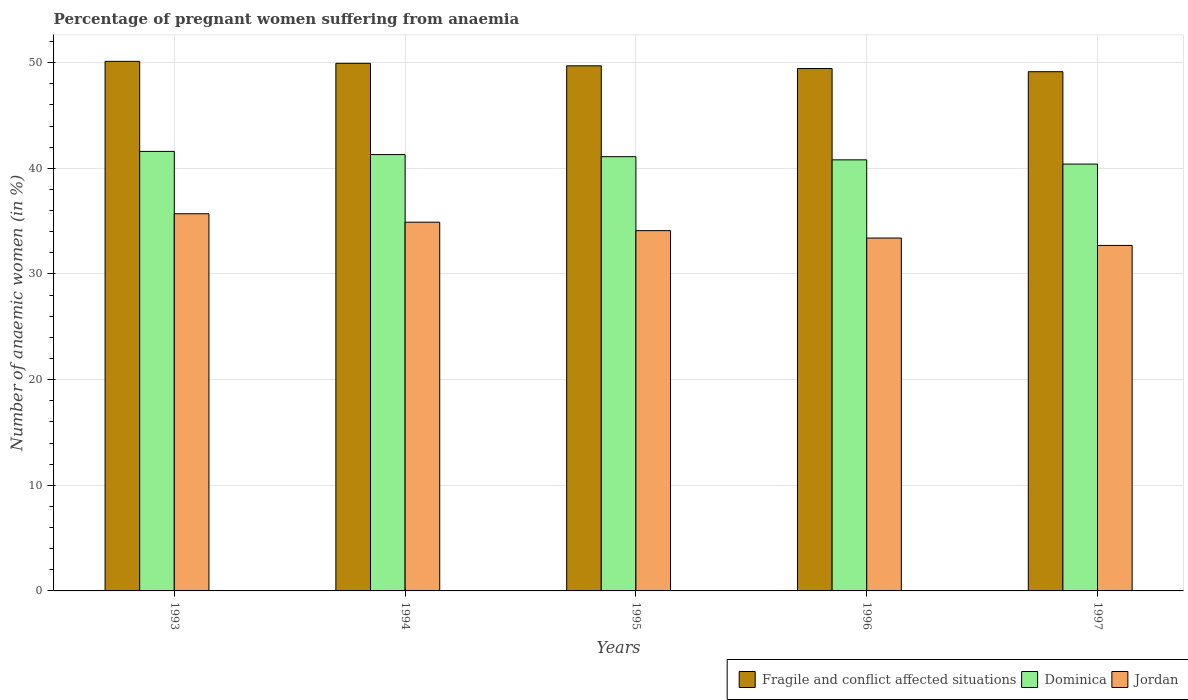How many groups of bars are there?
Provide a short and direct response. 5. How many bars are there on the 4th tick from the left?
Keep it short and to the point. 3. How many bars are there on the 1st tick from the right?
Give a very brief answer. 3. In how many cases, is the number of bars for a given year not equal to the number of legend labels?
Keep it short and to the point. 0. What is the number of anaemic women in Dominica in 1997?
Provide a succinct answer. 40.4. Across all years, what is the maximum number of anaemic women in Jordan?
Offer a terse response. 35.7. Across all years, what is the minimum number of anaemic women in Fragile and conflict affected situations?
Keep it short and to the point. 49.14. What is the total number of anaemic women in Dominica in the graph?
Offer a very short reply. 205.2. What is the difference between the number of anaemic women in Dominica in 1993 and the number of anaemic women in Fragile and conflict affected situations in 1995?
Your answer should be compact. -8.1. What is the average number of anaemic women in Fragile and conflict affected situations per year?
Keep it short and to the point. 49.67. In the year 1997, what is the difference between the number of anaemic women in Fragile and conflict affected situations and number of anaemic women in Jordan?
Offer a terse response. 16.44. In how many years, is the number of anaemic women in Jordan greater than 14 %?
Provide a succinct answer. 5. What is the ratio of the number of anaemic women in Fragile and conflict affected situations in 1994 to that in 1997?
Keep it short and to the point. 1.02. What is the difference between the highest and the second highest number of anaemic women in Jordan?
Your answer should be very brief. 0.8. What is the difference between the highest and the lowest number of anaemic women in Jordan?
Your response must be concise. 3. In how many years, is the number of anaemic women in Jordan greater than the average number of anaemic women in Jordan taken over all years?
Offer a very short reply. 2. What does the 3rd bar from the left in 1995 represents?
Make the answer very short. Jordan. What does the 1st bar from the right in 1996 represents?
Your answer should be compact. Jordan. Is it the case that in every year, the sum of the number of anaemic women in Dominica and number of anaemic women in Fragile and conflict affected situations is greater than the number of anaemic women in Jordan?
Your answer should be compact. Yes. How many bars are there?
Your answer should be very brief. 15. Are all the bars in the graph horizontal?
Your response must be concise. No. Does the graph contain grids?
Offer a very short reply. Yes. Where does the legend appear in the graph?
Make the answer very short. Bottom right. How many legend labels are there?
Your answer should be compact. 3. How are the legend labels stacked?
Keep it short and to the point. Horizontal. What is the title of the graph?
Offer a terse response. Percentage of pregnant women suffering from anaemia. Does "Ghana" appear as one of the legend labels in the graph?
Your answer should be very brief. No. What is the label or title of the X-axis?
Give a very brief answer. Years. What is the label or title of the Y-axis?
Your answer should be very brief. Number of anaemic women (in %). What is the Number of anaemic women (in %) in Fragile and conflict affected situations in 1993?
Provide a succinct answer. 50.12. What is the Number of anaemic women (in %) of Dominica in 1993?
Give a very brief answer. 41.6. What is the Number of anaemic women (in %) in Jordan in 1993?
Make the answer very short. 35.7. What is the Number of anaemic women (in %) of Fragile and conflict affected situations in 1994?
Keep it short and to the point. 49.94. What is the Number of anaemic women (in %) in Dominica in 1994?
Keep it short and to the point. 41.3. What is the Number of anaemic women (in %) of Jordan in 1994?
Your answer should be compact. 34.9. What is the Number of anaemic women (in %) of Fragile and conflict affected situations in 1995?
Your response must be concise. 49.7. What is the Number of anaemic women (in %) in Dominica in 1995?
Offer a terse response. 41.1. What is the Number of anaemic women (in %) of Jordan in 1995?
Provide a succinct answer. 34.1. What is the Number of anaemic women (in %) of Fragile and conflict affected situations in 1996?
Offer a very short reply. 49.44. What is the Number of anaemic women (in %) in Dominica in 1996?
Your answer should be very brief. 40.8. What is the Number of anaemic women (in %) of Jordan in 1996?
Your answer should be very brief. 33.4. What is the Number of anaemic women (in %) of Fragile and conflict affected situations in 1997?
Keep it short and to the point. 49.14. What is the Number of anaemic women (in %) in Dominica in 1997?
Make the answer very short. 40.4. What is the Number of anaemic women (in %) in Jordan in 1997?
Give a very brief answer. 32.7. Across all years, what is the maximum Number of anaemic women (in %) in Fragile and conflict affected situations?
Provide a succinct answer. 50.12. Across all years, what is the maximum Number of anaemic women (in %) in Dominica?
Your response must be concise. 41.6. Across all years, what is the maximum Number of anaemic women (in %) in Jordan?
Provide a succinct answer. 35.7. Across all years, what is the minimum Number of anaemic women (in %) in Fragile and conflict affected situations?
Provide a succinct answer. 49.14. Across all years, what is the minimum Number of anaemic women (in %) in Dominica?
Keep it short and to the point. 40.4. Across all years, what is the minimum Number of anaemic women (in %) in Jordan?
Provide a short and direct response. 32.7. What is the total Number of anaemic women (in %) of Fragile and conflict affected situations in the graph?
Provide a succinct answer. 248.35. What is the total Number of anaemic women (in %) of Dominica in the graph?
Your answer should be very brief. 205.2. What is the total Number of anaemic women (in %) in Jordan in the graph?
Provide a succinct answer. 170.8. What is the difference between the Number of anaemic women (in %) in Fragile and conflict affected situations in 1993 and that in 1994?
Your answer should be very brief. 0.18. What is the difference between the Number of anaemic women (in %) of Dominica in 1993 and that in 1994?
Ensure brevity in your answer.  0.3. What is the difference between the Number of anaemic women (in %) in Fragile and conflict affected situations in 1993 and that in 1995?
Provide a succinct answer. 0.42. What is the difference between the Number of anaemic women (in %) of Dominica in 1993 and that in 1995?
Offer a terse response. 0.5. What is the difference between the Number of anaemic women (in %) of Jordan in 1993 and that in 1995?
Make the answer very short. 1.6. What is the difference between the Number of anaemic women (in %) of Fragile and conflict affected situations in 1993 and that in 1996?
Provide a succinct answer. 0.68. What is the difference between the Number of anaemic women (in %) in Dominica in 1993 and that in 1996?
Offer a terse response. 0.8. What is the difference between the Number of anaemic women (in %) of Fragile and conflict affected situations in 1993 and that in 1997?
Your answer should be compact. 0.98. What is the difference between the Number of anaemic women (in %) in Dominica in 1993 and that in 1997?
Provide a short and direct response. 1.2. What is the difference between the Number of anaemic women (in %) of Jordan in 1993 and that in 1997?
Make the answer very short. 3. What is the difference between the Number of anaemic women (in %) of Fragile and conflict affected situations in 1994 and that in 1995?
Provide a succinct answer. 0.24. What is the difference between the Number of anaemic women (in %) of Fragile and conflict affected situations in 1994 and that in 1996?
Your response must be concise. 0.49. What is the difference between the Number of anaemic women (in %) in Jordan in 1994 and that in 1996?
Ensure brevity in your answer.  1.5. What is the difference between the Number of anaemic women (in %) in Fragile and conflict affected situations in 1994 and that in 1997?
Offer a terse response. 0.8. What is the difference between the Number of anaemic women (in %) of Fragile and conflict affected situations in 1995 and that in 1996?
Provide a succinct answer. 0.26. What is the difference between the Number of anaemic women (in %) in Jordan in 1995 and that in 1996?
Provide a succinct answer. 0.7. What is the difference between the Number of anaemic women (in %) of Fragile and conflict affected situations in 1995 and that in 1997?
Provide a succinct answer. 0.56. What is the difference between the Number of anaemic women (in %) in Fragile and conflict affected situations in 1996 and that in 1997?
Give a very brief answer. 0.3. What is the difference between the Number of anaemic women (in %) of Dominica in 1996 and that in 1997?
Your answer should be compact. 0.4. What is the difference between the Number of anaemic women (in %) of Jordan in 1996 and that in 1997?
Ensure brevity in your answer.  0.7. What is the difference between the Number of anaemic women (in %) of Fragile and conflict affected situations in 1993 and the Number of anaemic women (in %) of Dominica in 1994?
Offer a terse response. 8.82. What is the difference between the Number of anaemic women (in %) in Fragile and conflict affected situations in 1993 and the Number of anaemic women (in %) in Jordan in 1994?
Keep it short and to the point. 15.22. What is the difference between the Number of anaemic women (in %) of Dominica in 1993 and the Number of anaemic women (in %) of Jordan in 1994?
Provide a short and direct response. 6.7. What is the difference between the Number of anaemic women (in %) of Fragile and conflict affected situations in 1993 and the Number of anaemic women (in %) of Dominica in 1995?
Offer a very short reply. 9.02. What is the difference between the Number of anaemic women (in %) in Fragile and conflict affected situations in 1993 and the Number of anaemic women (in %) in Jordan in 1995?
Offer a very short reply. 16.02. What is the difference between the Number of anaemic women (in %) of Dominica in 1993 and the Number of anaemic women (in %) of Jordan in 1995?
Give a very brief answer. 7.5. What is the difference between the Number of anaemic women (in %) in Fragile and conflict affected situations in 1993 and the Number of anaemic women (in %) in Dominica in 1996?
Keep it short and to the point. 9.32. What is the difference between the Number of anaemic women (in %) of Fragile and conflict affected situations in 1993 and the Number of anaemic women (in %) of Jordan in 1996?
Provide a short and direct response. 16.72. What is the difference between the Number of anaemic women (in %) of Dominica in 1993 and the Number of anaemic women (in %) of Jordan in 1996?
Provide a short and direct response. 8.2. What is the difference between the Number of anaemic women (in %) in Fragile and conflict affected situations in 1993 and the Number of anaemic women (in %) in Dominica in 1997?
Offer a very short reply. 9.72. What is the difference between the Number of anaemic women (in %) in Fragile and conflict affected situations in 1993 and the Number of anaemic women (in %) in Jordan in 1997?
Give a very brief answer. 17.42. What is the difference between the Number of anaemic women (in %) of Fragile and conflict affected situations in 1994 and the Number of anaemic women (in %) of Dominica in 1995?
Offer a very short reply. 8.84. What is the difference between the Number of anaemic women (in %) of Fragile and conflict affected situations in 1994 and the Number of anaemic women (in %) of Jordan in 1995?
Ensure brevity in your answer.  15.84. What is the difference between the Number of anaemic women (in %) of Fragile and conflict affected situations in 1994 and the Number of anaemic women (in %) of Dominica in 1996?
Your response must be concise. 9.14. What is the difference between the Number of anaemic women (in %) in Fragile and conflict affected situations in 1994 and the Number of anaemic women (in %) in Jordan in 1996?
Give a very brief answer. 16.54. What is the difference between the Number of anaemic women (in %) in Fragile and conflict affected situations in 1994 and the Number of anaemic women (in %) in Dominica in 1997?
Your response must be concise. 9.54. What is the difference between the Number of anaemic women (in %) in Fragile and conflict affected situations in 1994 and the Number of anaemic women (in %) in Jordan in 1997?
Make the answer very short. 17.24. What is the difference between the Number of anaemic women (in %) in Fragile and conflict affected situations in 1995 and the Number of anaemic women (in %) in Dominica in 1996?
Make the answer very short. 8.9. What is the difference between the Number of anaemic women (in %) of Fragile and conflict affected situations in 1995 and the Number of anaemic women (in %) of Jordan in 1996?
Offer a very short reply. 16.3. What is the difference between the Number of anaemic women (in %) of Dominica in 1995 and the Number of anaemic women (in %) of Jordan in 1996?
Your answer should be very brief. 7.7. What is the difference between the Number of anaemic women (in %) of Fragile and conflict affected situations in 1995 and the Number of anaemic women (in %) of Dominica in 1997?
Your answer should be very brief. 9.3. What is the difference between the Number of anaemic women (in %) in Fragile and conflict affected situations in 1995 and the Number of anaemic women (in %) in Jordan in 1997?
Your answer should be very brief. 17. What is the difference between the Number of anaemic women (in %) of Dominica in 1995 and the Number of anaemic women (in %) of Jordan in 1997?
Provide a short and direct response. 8.4. What is the difference between the Number of anaemic women (in %) in Fragile and conflict affected situations in 1996 and the Number of anaemic women (in %) in Dominica in 1997?
Give a very brief answer. 9.04. What is the difference between the Number of anaemic women (in %) in Fragile and conflict affected situations in 1996 and the Number of anaemic women (in %) in Jordan in 1997?
Your answer should be very brief. 16.74. What is the average Number of anaemic women (in %) of Fragile and conflict affected situations per year?
Provide a succinct answer. 49.67. What is the average Number of anaemic women (in %) of Dominica per year?
Your answer should be compact. 41.04. What is the average Number of anaemic women (in %) of Jordan per year?
Offer a terse response. 34.16. In the year 1993, what is the difference between the Number of anaemic women (in %) of Fragile and conflict affected situations and Number of anaemic women (in %) of Dominica?
Provide a short and direct response. 8.52. In the year 1993, what is the difference between the Number of anaemic women (in %) in Fragile and conflict affected situations and Number of anaemic women (in %) in Jordan?
Provide a succinct answer. 14.42. In the year 1994, what is the difference between the Number of anaemic women (in %) in Fragile and conflict affected situations and Number of anaemic women (in %) in Dominica?
Provide a succinct answer. 8.64. In the year 1994, what is the difference between the Number of anaemic women (in %) in Fragile and conflict affected situations and Number of anaemic women (in %) in Jordan?
Provide a succinct answer. 15.04. In the year 1995, what is the difference between the Number of anaemic women (in %) of Fragile and conflict affected situations and Number of anaemic women (in %) of Dominica?
Keep it short and to the point. 8.6. In the year 1995, what is the difference between the Number of anaemic women (in %) of Fragile and conflict affected situations and Number of anaemic women (in %) of Jordan?
Give a very brief answer. 15.6. In the year 1996, what is the difference between the Number of anaemic women (in %) of Fragile and conflict affected situations and Number of anaemic women (in %) of Dominica?
Keep it short and to the point. 8.64. In the year 1996, what is the difference between the Number of anaemic women (in %) in Fragile and conflict affected situations and Number of anaemic women (in %) in Jordan?
Provide a succinct answer. 16.04. In the year 1996, what is the difference between the Number of anaemic women (in %) of Dominica and Number of anaemic women (in %) of Jordan?
Provide a succinct answer. 7.4. In the year 1997, what is the difference between the Number of anaemic women (in %) in Fragile and conflict affected situations and Number of anaemic women (in %) in Dominica?
Offer a very short reply. 8.74. In the year 1997, what is the difference between the Number of anaemic women (in %) in Fragile and conflict affected situations and Number of anaemic women (in %) in Jordan?
Make the answer very short. 16.44. In the year 1997, what is the difference between the Number of anaemic women (in %) in Dominica and Number of anaemic women (in %) in Jordan?
Your answer should be very brief. 7.7. What is the ratio of the Number of anaemic women (in %) in Dominica in 1993 to that in 1994?
Your answer should be compact. 1.01. What is the ratio of the Number of anaemic women (in %) of Jordan in 1993 to that in 1994?
Ensure brevity in your answer.  1.02. What is the ratio of the Number of anaemic women (in %) in Fragile and conflict affected situations in 1993 to that in 1995?
Give a very brief answer. 1.01. What is the ratio of the Number of anaemic women (in %) of Dominica in 1993 to that in 1995?
Your answer should be compact. 1.01. What is the ratio of the Number of anaemic women (in %) in Jordan in 1993 to that in 1995?
Keep it short and to the point. 1.05. What is the ratio of the Number of anaemic women (in %) of Fragile and conflict affected situations in 1993 to that in 1996?
Your answer should be very brief. 1.01. What is the ratio of the Number of anaemic women (in %) in Dominica in 1993 to that in 1996?
Make the answer very short. 1.02. What is the ratio of the Number of anaemic women (in %) of Jordan in 1993 to that in 1996?
Offer a very short reply. 1.07. What is the ratio of the Number of anaemic women (in %) of Fragile and conflict affected situations in 1993 to that in 1997?
Provide a short and direct response. 1.02. What is the ratio of the Number of anaemic women (in %) of Dominica in 1993 to that in 1997?
Give a very brief answer. 1.03. What is the ratio of the Number of anaemic women (in %) of Jordan in 1993 to that in 1997?
Your response must be concise. 1.09. What is the ratio of the Number of anaemic women (in %) of Fragile and conflict affected situations in 1994 to that in 1995?
Ensure brevity in your answer.  1. What is the ratio of the Number of anaemic women (in %) of Jordan in 1994 to that in 1995?
Keep it short and to the point. 1.02. What is the ratio of the Number of anaemic women (in %) of Dominica in 1994 to that in 1996?
Make the answer very short. 1.01. What is the ratio of the Number of anaemic women (in %) of Jordan in 1994 to that in 1996?
Give a very brief answer. 1.04. What is the ratio of the Number of anaemic women (in %) of Fragile and conflict affected situations in 1994 to that in 1997?
Your answer should be very brief. 1.02. What is the ratio of the Number of anaemic women (in %) of Dominica in 1994 to that in 1997?
Keep it short and to the point. 1.02. What is the ratio of the Number of anaemic women (in %) of Jordan in 1994 to that in 1997?
Give a very brief answer. 1.07. What is the ratio of the Number of anaemic women (in %) in Fragile and conflict affected situations in 1995 to that in 1996?
Give a very brief answer. 1.01. What is the ratio of the Number of anaemic women (in %) in Dominica in 1995 to that in 1996?
Offer a terse response. 1.01. What is the ratio of the Number of anaemic women (in %) in Jordan in 1995 to that in 1996?
Keep it short and to the point. 1.02. What is the ratio of the Number of anaemic women (in %) of Fragile and conflict affected situations in 1995 to that in 1997?
Your answer should be compact. 1.01. What is the ratio of the Number of anaemic women (in %) in Dominica in 1995 to that in 1997?
Your response must be concise. 1.02. What is the ratio of the Number of anaemic women (in %) in Jordan in 1995 to that in 1997?
Ensure brevity in your answer.  1.04. What is the ratio of the Number of anaemic women (in %) in Fragile and conflict affected situations in 1996 to that in 1997?
Keep it short and to the point. 1.01. What is the ratio of the Number of anaemic women (in %) of Dominica in 1996 to that in 1997?
Provide a succinct answer. 1.01. What is the ratio of the Number of anaemic women (in %) of Jordan in 1996 to that in 1997?
Make the answer very short. 1.02. What is the difference between the highest and the second highest Number of anaemic women (in %) of Fragile and conflict affected situations?
Offer a very short reply. 0.18. What is the difference between the highest and the second highest Number of anaemic women (in %) in Dominica?
Ensure brevity in your answer.  0.3. What is the difference between the highest and the second highest Number of anaemic women (in %) in Jordan?
Your response must be concise. 0.8. What is the difference between the highest and the lowest Number of anaemic women (in %) in Fragile and conflict affected situations?
Keep it short and to the point. 0.98. What is the difference between the highest and the lowest Number of anaemic women (in %) in Jordan?
Give a very brief answer. 3. 